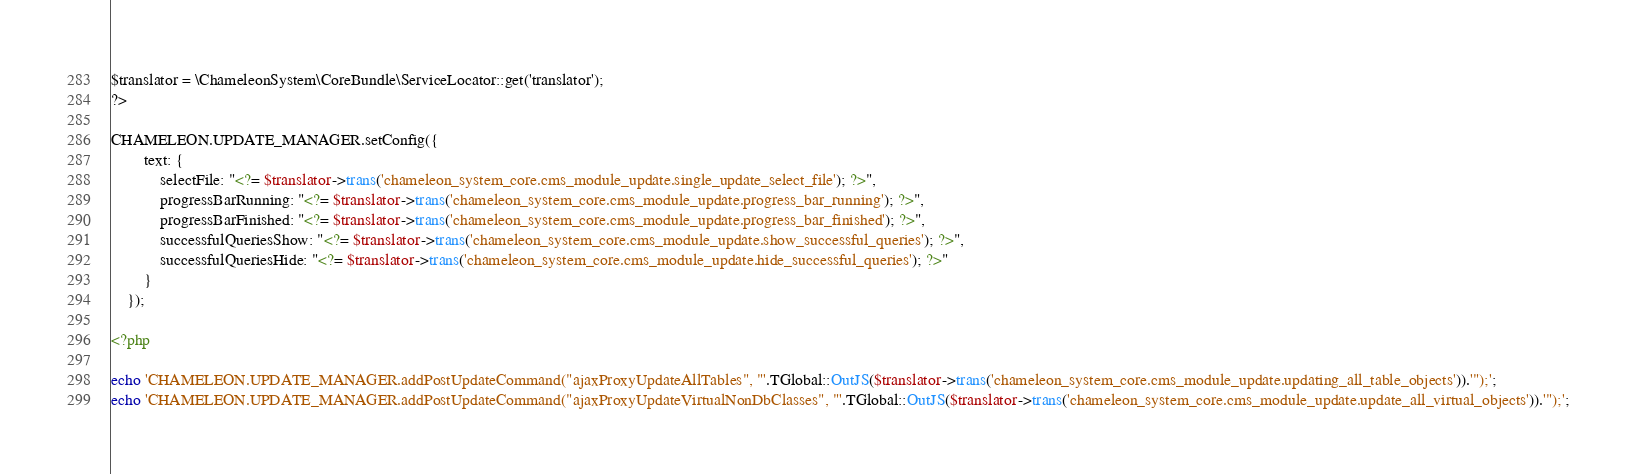<code> <loc_0><loc_0><loc_500><loc_500><_PHP_>$translator = \ChameleonSystem\CoreBundle\ServiceLocator::get('translator');
?>

CHAMELEON.UPDATE_MANAGER.setConfig({
        text: {
            selectFile: "<?= $translator->trans('chameleon_system_core.cms_module_update.single_update_select_file'); ?>",
            progressBarRunning: "<?= $translator->trans('chameleon_system_core.cms_module_update.progress_bar_running'); ?>",
            progressBarFinished: "<?= $translator->trans('chameleon_system_core.cms_module_update.progress_bar_finished'); ?>",
            successfulQueriesShow: "<?= $translator->trans('chameleon_system_core.cms_module_update.show_successful_queries'); ?>",
            successfulQueriesHide: "<?= $translator->trans('chameleon_system_core.cms_module_update.hide_successful_queries'); ?>"
        }
    });

<?php

echo 'CHAMELEON.UPDATE_MANAGER.addPostUpdateCommand("ajaxProxyUpdateAllTables", "'.TGlobal::OutJS($translator->trans('chameleon_system_core.cms_module_update.updating_all_table_objects')).'");';
echo 'CHAMELEON.UPDATE_MANAGER.addPostUpdateCommand("ajaxProxyUpdateVirtualNonDbClasses", "'.TGlobal::OutJS($translator->trans('chameleon_system_core.cms_module_update.update_all_virtual_objects')).'");';
</code> 